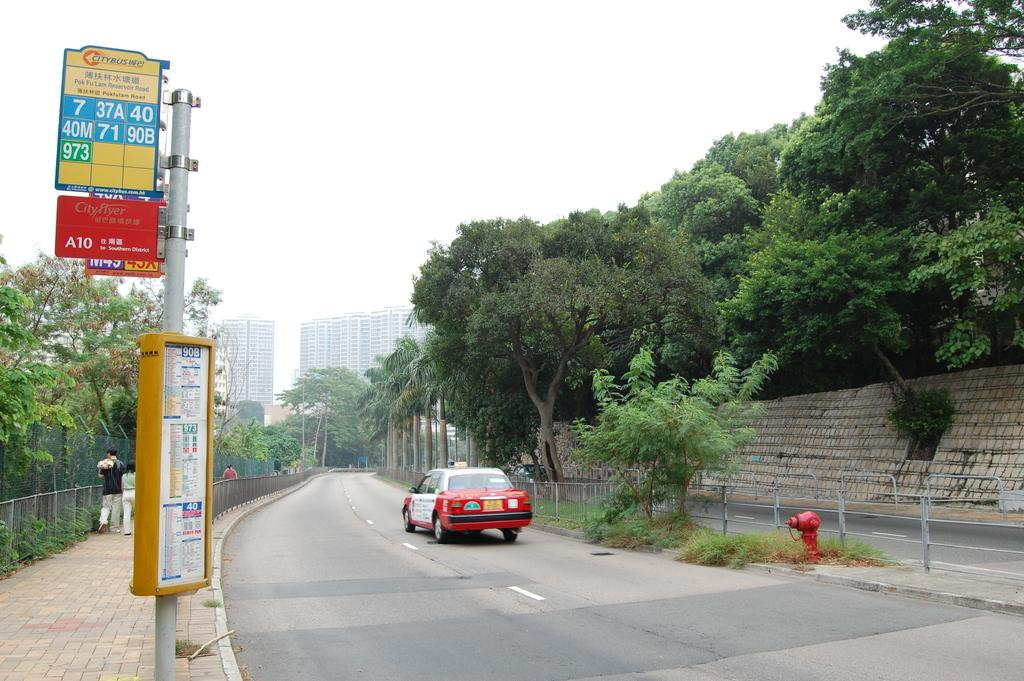Provide a one-sentence caption for the provided image. A quiet road has a Citybus stop and one lone cab driving down the street. 